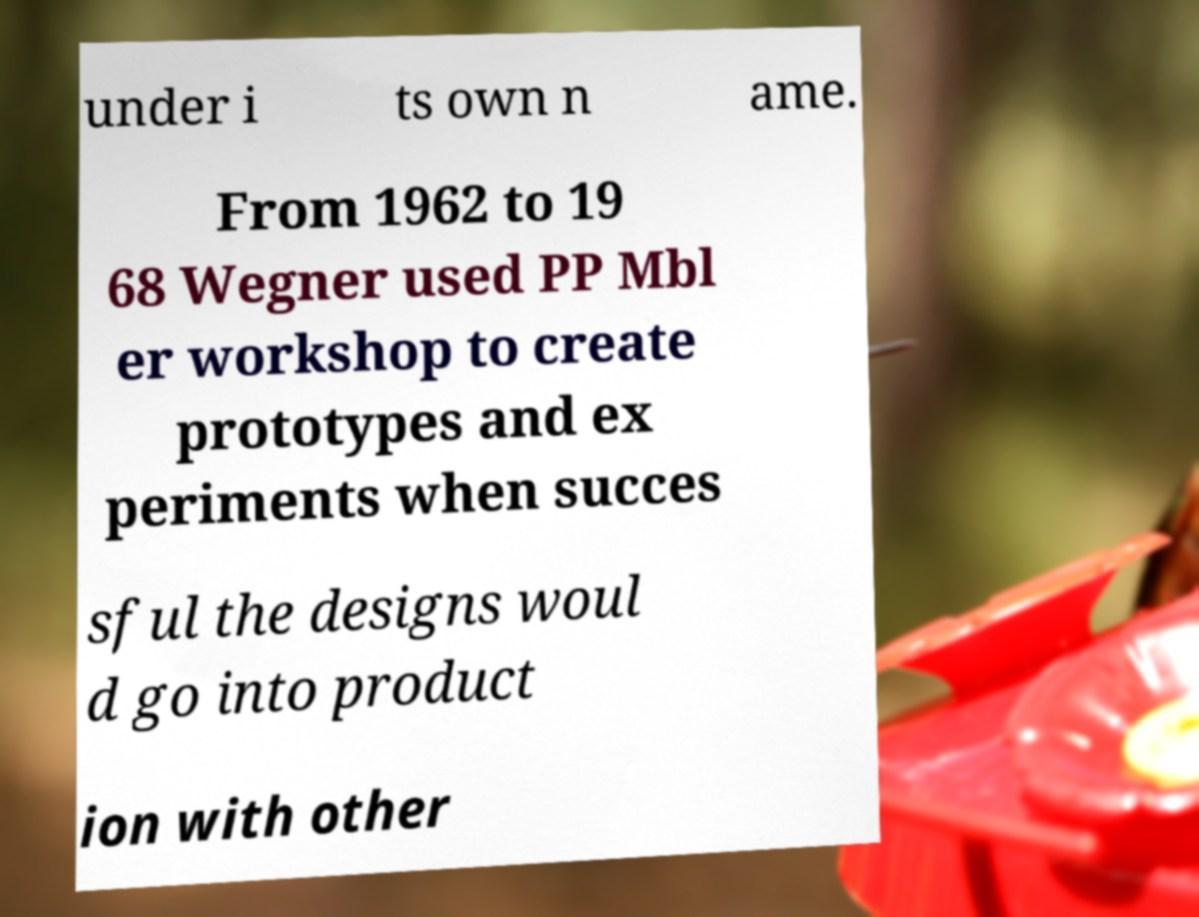Can you read and provide the text displayed in the image?This photo seems to have some interesting text. Can you extract and type it out for me? under i ts own n ame. From 1962 to 19 68 Wegner used PP Mbl er workshop to create prototypes and ex periments when succes sful the designs woul d go into product ion with other 